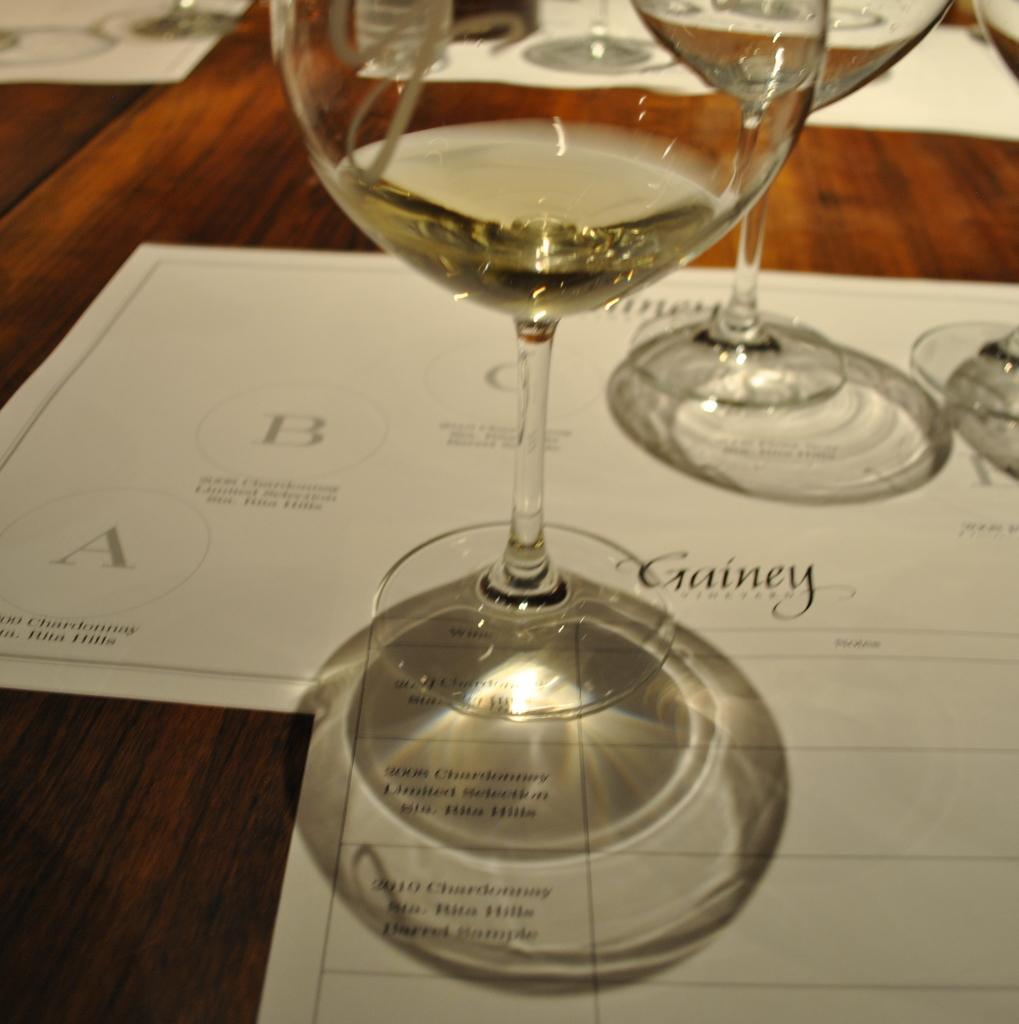Could you give a brief overview of what you see in this image? In this image there is a table on which there are three glasses on the papers. On the table there are few papers. 